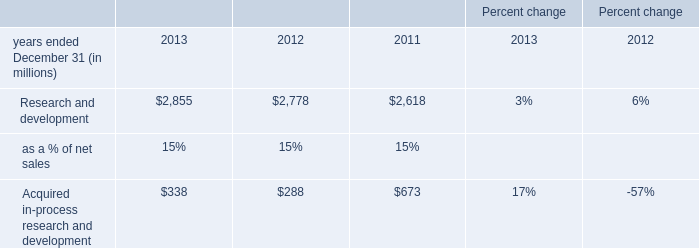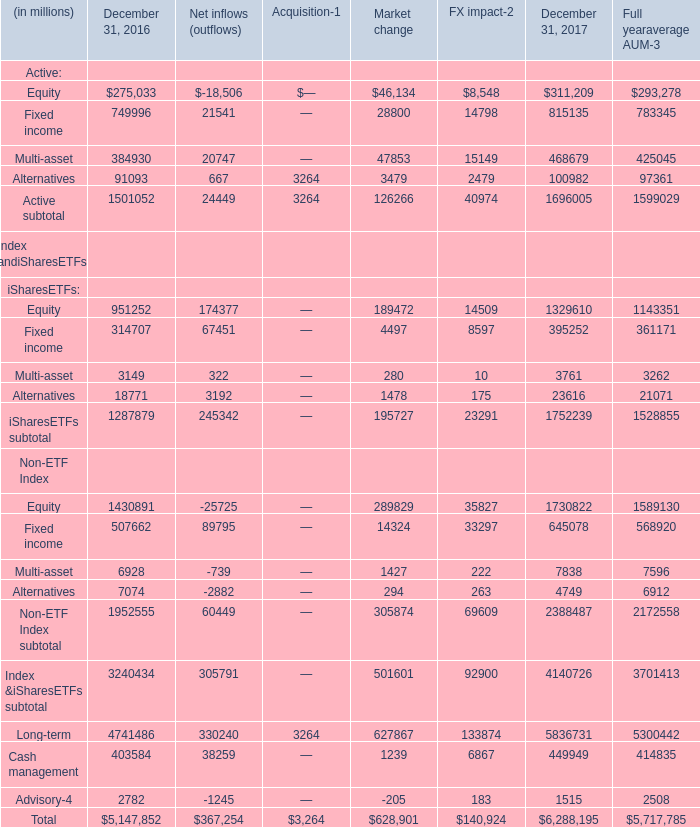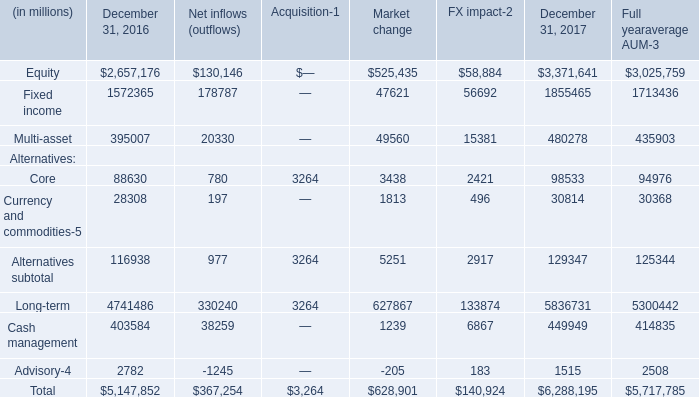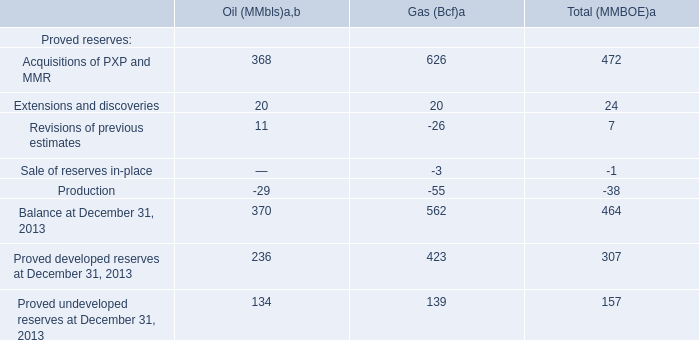If Long-term develops with the same increasing rate in 2017, what will it reach in 2018? (in million) 
Computations: (5836731 * (1 + ((5836731 - 4741486) / 4741486)))
Answer: 7184968.75586. 